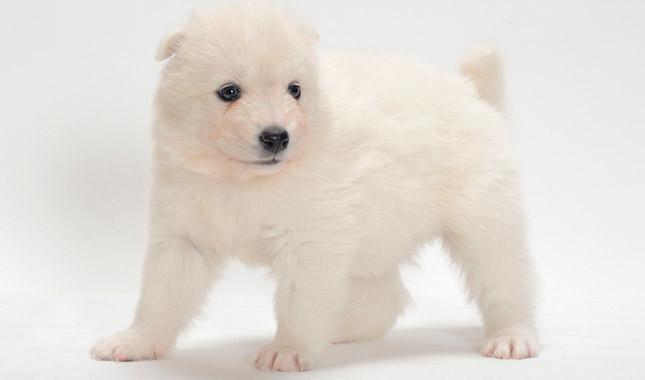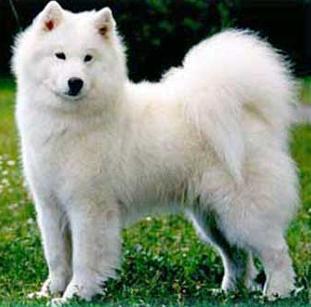The first image is the image on the left, the second image is the image on the right. Considering the images on both sides, is "The dogs have their mouths open." valid? Answer yes or no. No. 